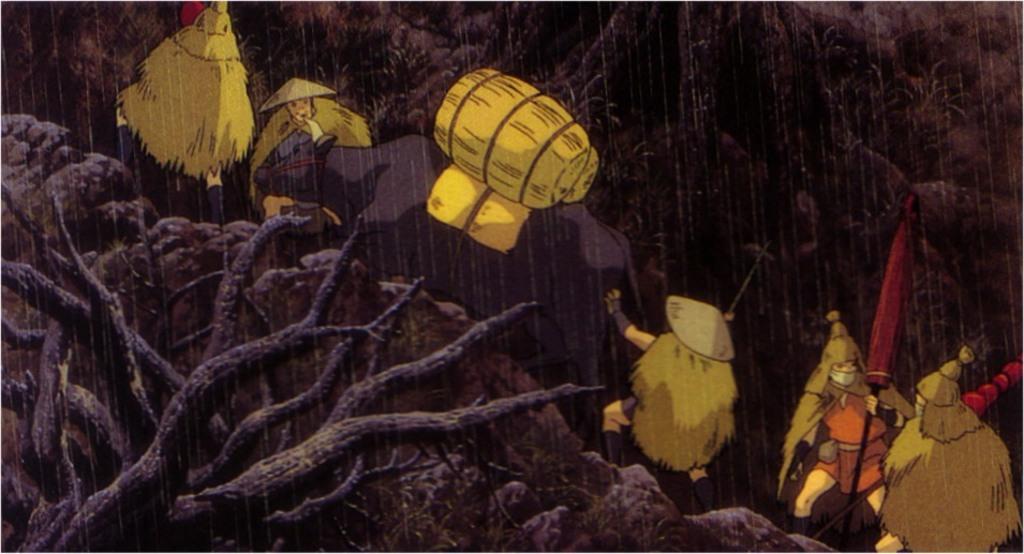Describe this image in one or two sentences. This is an animated image. In this image, we can see a few people standing and holding weapons in their hands. In the middle of the image, we can also see an animal. In the left corner, we can also see wooden trunk. In the background, we can see a rain, trees and yellow color. 